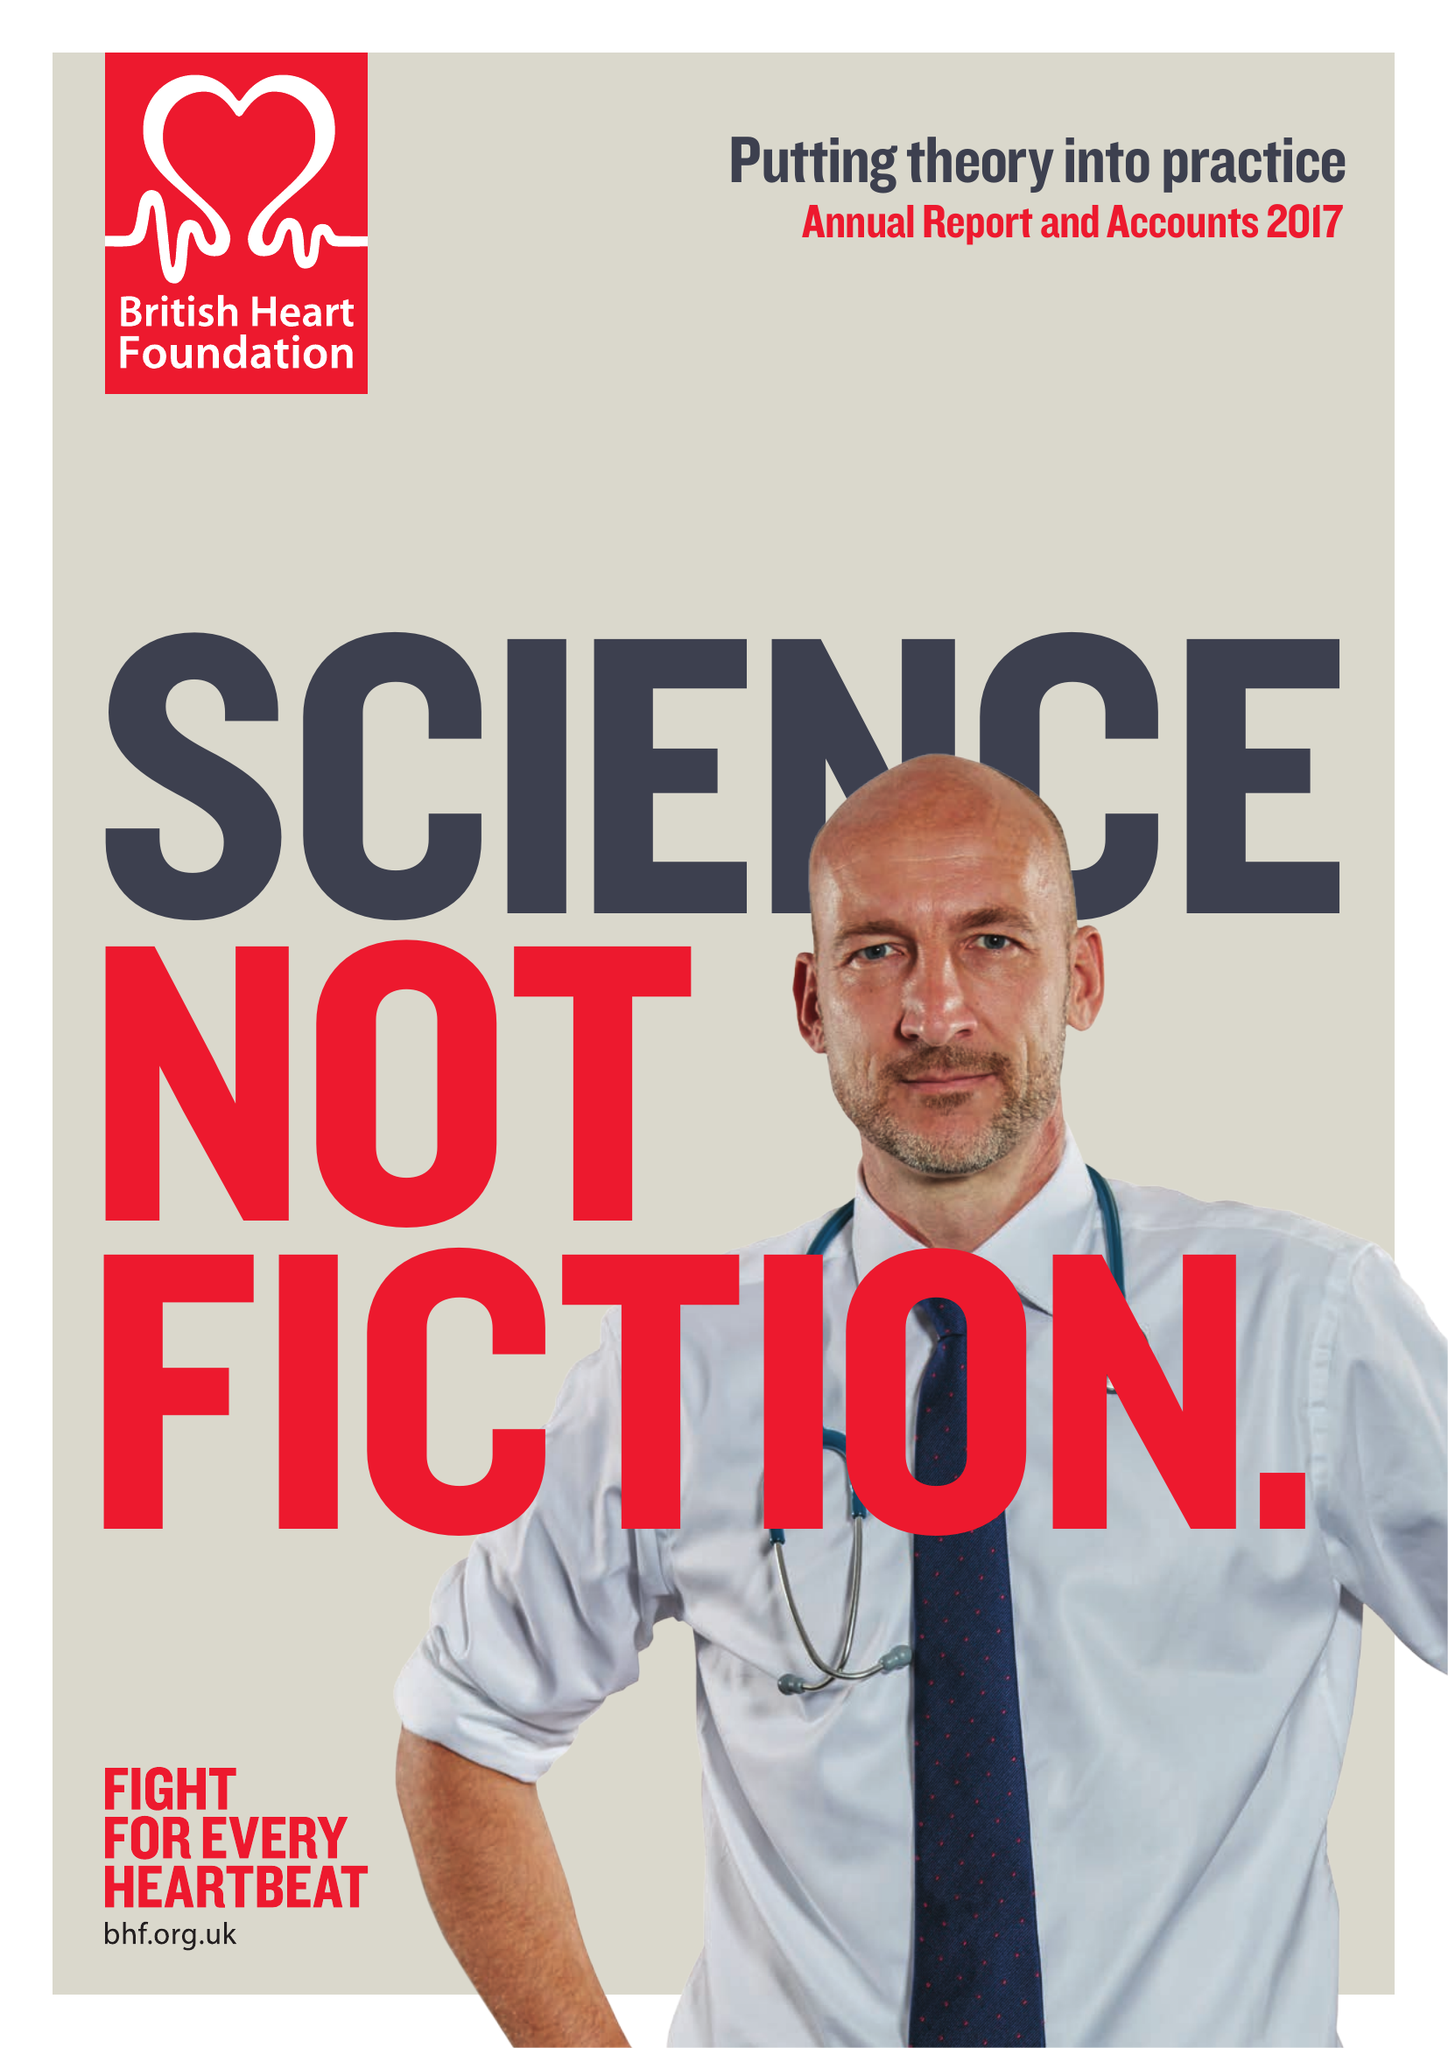What is the value for the charity_name?
Answer the question using a single word or phrase. British Heart Foundation 